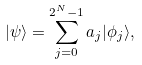Convert formula to latex. <formula><loc_0><loc_0><loc_500><loc_500>| \psi \rangle = \sum _ { j = 0 } ^ { 2 ^ { N } - 1 } a _ { j } | \phi _ { j } \rangle ,</formula> 